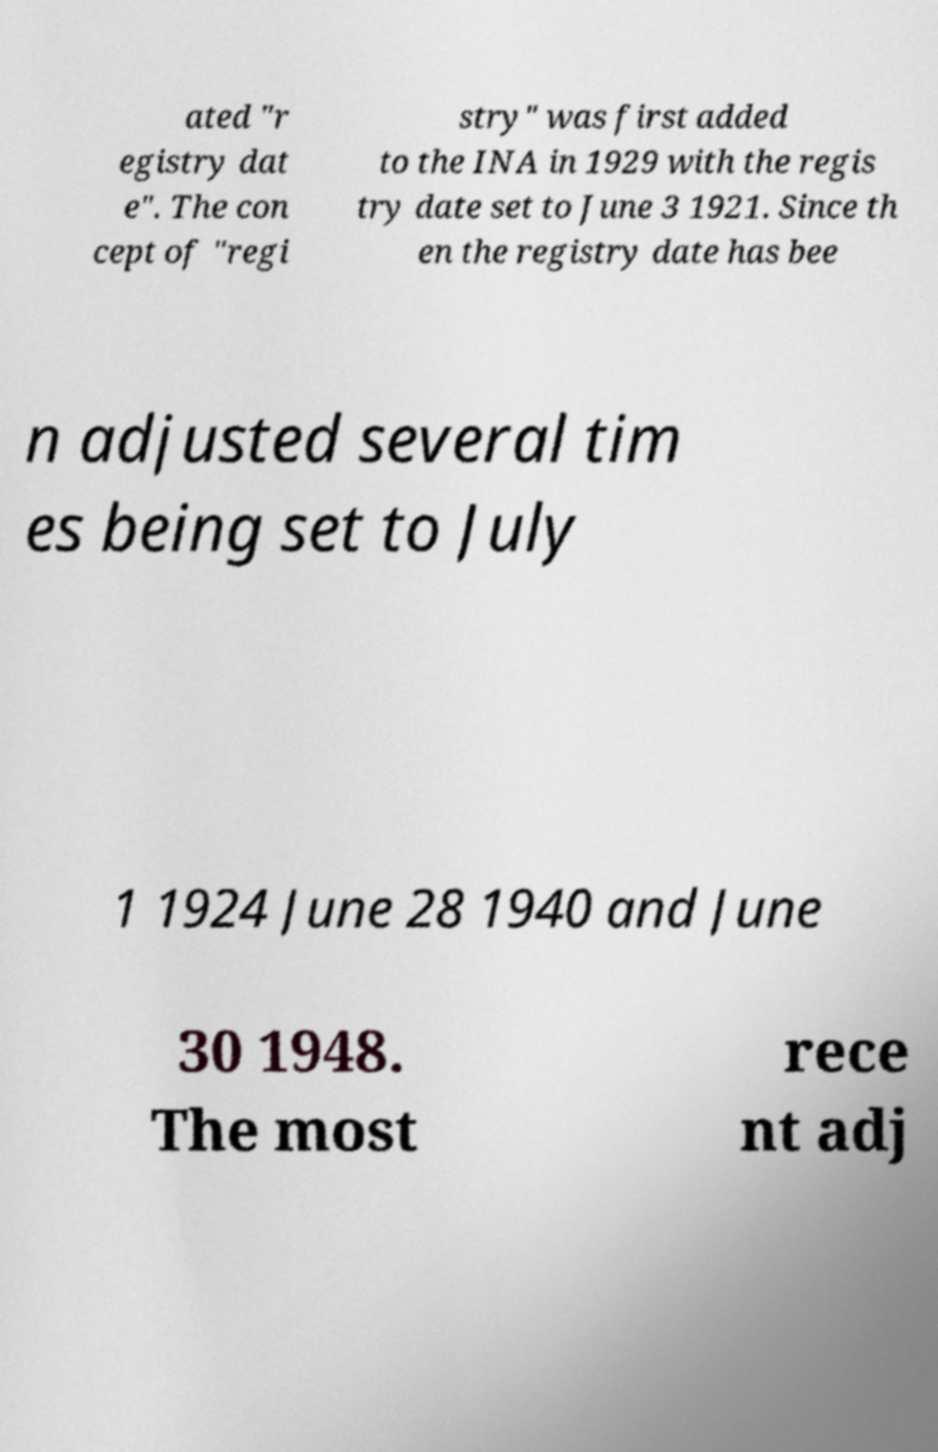Please identify and transcribe the text found in this image. ated "r egistry dat e". The con cept of "regi stry" was first added to the INA in 1929 with the regis try date set to June 3 1921. Since th en the registry date has bee n adjusted several tim es being set to July 1 1924 June 28 1940 and June 30 1948. The most rece nt adj 